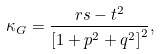Convert formula to latex. <formula><loc_0><loc_0><loc_500><loc_500>\kappa _ { G } = \frac { r s - t ^ { 2 } } { \left [ 1 + p ^ { 2 } + q ^ { 2 } \right ] ^ { 2 } } ,</formula> 